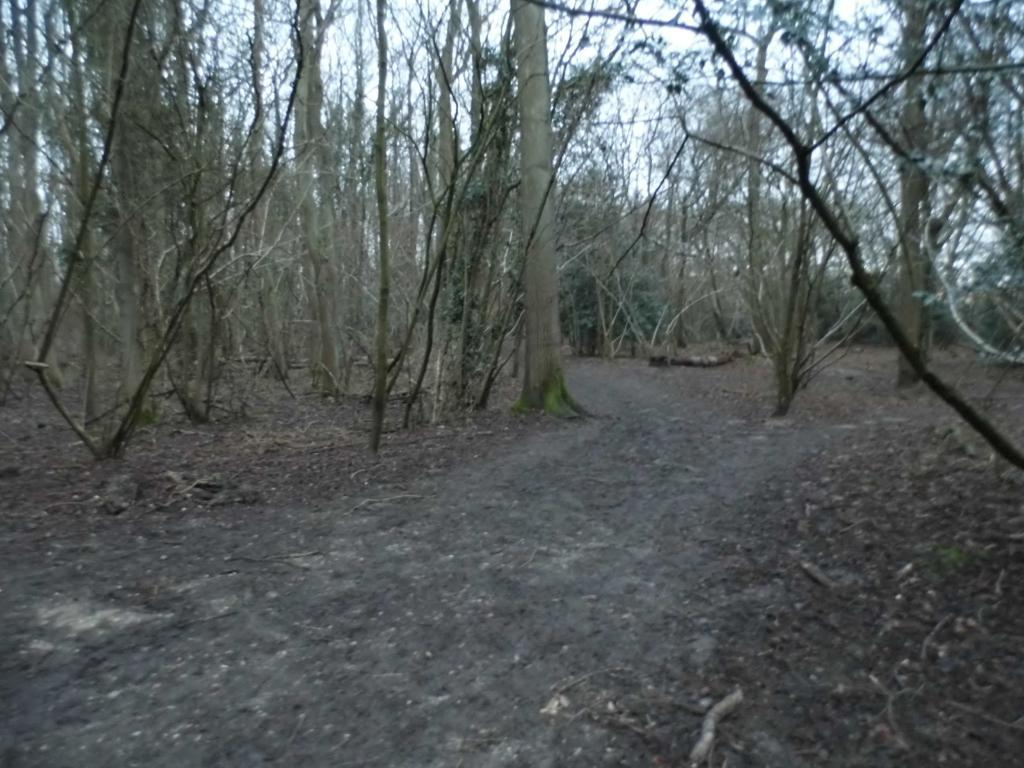What can be seen in the image that people might walk on? There is a path in the image that people might walk on. What type of natural scenery is visible in the background of the image? There are trees in the background of the image. What type of paste is being used to create the border in the image? There is no border or paste present in the image; it features a path and trees in the background. 